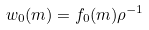Convert formula to latex. <formula><loc_0><loc_0><loc_500><loc_500>w _ { 0 } ( m ) = f _ { 0 } ( m ) \rho ^ { - 1 }</formula> 